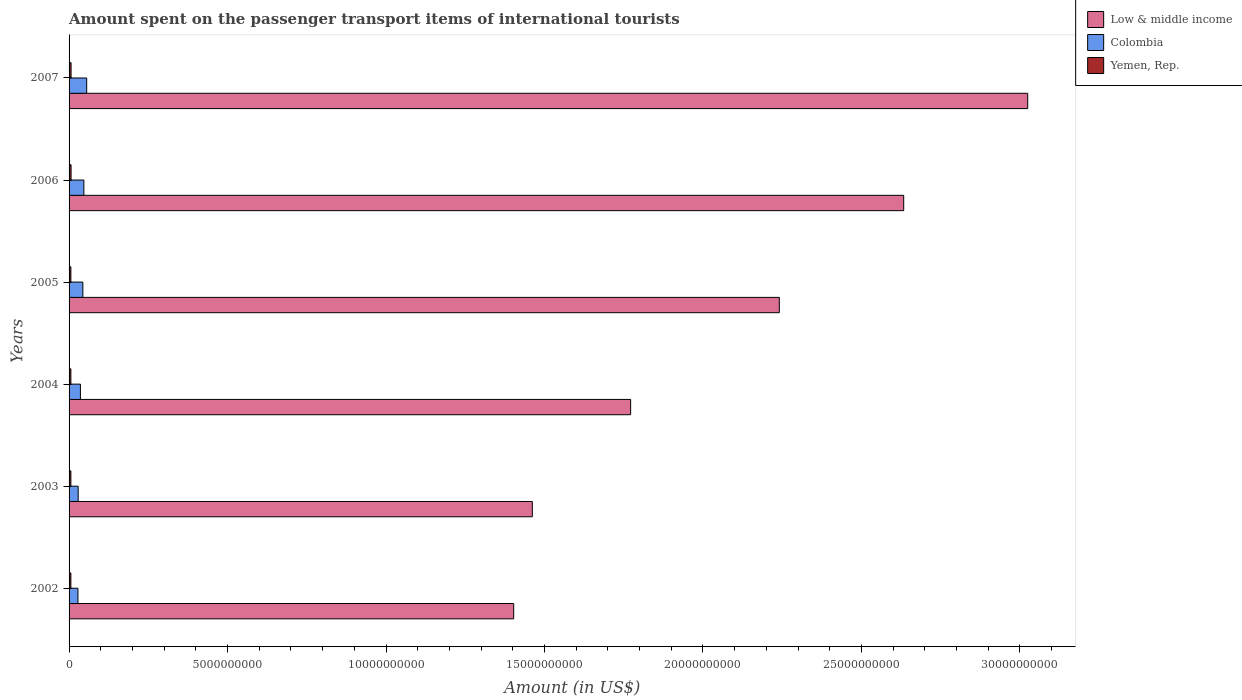How many different coloured bars are there?
Keep it short and to the point. 3. How many groups of bars are there?
Your answer should be very brief. 6. Are the number of bars per tick equal to the number of legend labels?
Provide a succinct answer. Yes. Are the number of bars on each tick of the Y-axis equal?
Make the answer very short. Yes. What is the amount spent on the passenger transport items of international tourists in Low & middle income in 2006?
Offer a terse response. 2.63e+1. Across all years, what is the maximum amount spent on the passenger transport items of international tourists in Low & middle income?
Provide a short and direct response. 3.02e+1. Across all years, what is the minimum amount spent on the passenger transport items of international tourists in Low & middle income?
Provide a succinct answer. 1.40e+1. In which year was the amount spent on the passenger transport items of international tourists in Yemen, Rep. maximum?
Offer a very short reply. 2006. What is the total amount spent on the passenger transport items of international tourists in Low & middle income in the graph?
Provide a short and direct response. 1.25e+11. What is the difference between the amount spent on the passenger transport items of international tourists in Low & middle income in 2005 and that in 2007?
Give a very brief answer. -7.84e+09. What is the difference between the amount spent on the passenger transport items of international tourists in Yemen, Rep. in 2005 and the amount spent on the passenger transport items of international tourists in Colombia in 2007?
Offer a very short reply. -4.99e+08. What is the average amount spent on the passenger transport items of international tourists in Yemen, Rep. per year?
Ensure brevity in your answer.  5.90e+07. In the year 2004, what is the difference between the amount spent on the passenger transport items of international tourists in Yemen, Rep. and amount spent on the passenger transport items of international tourists in Low & middle income?
Your response must be concise. -1.77e+1. In how many years, is the amount spent on the passenger transport items of international tourists in Yemen, Rep. greater than 3000000000 US$?
Ensure brevity in your answer.  0. What is the ratio of the amount spent on the passenger transport items of international tourists in Low & middle income in 2002 to that in 2003?
Your answer should be very brief. 0.96. Is the amount spent on the passenger transport items of international tourists in Colombia in 2003 less than that in 2005?
Your answer should be compact. Yes. What is the difference between the highest and the second highest amount spent on the passenger transport items of international tourists in Colombia?
Offer a terse response. 8.90e+07. What is the difference between the highest and the lowest amount spent on the passenger transport items of international tourists in Yemen, Rep.?
Provide a succinct answer. 6.00e+06. In how many years, is the amount spent on the passenger transport items of international tourists in Yemen, Rep. greater than the average amount spent on the passenger transport items of international tourists in Yemen, Rep. taken over all years?
Ensure brevity in your answer.  2. What does the 3rd bar from the top in 2007 represents?
Offer a very short reply. Low & middle income. What does the 3rd bar from the bottom in 2007 represents?
Make the answer very short. Yemen, Rep. How many bars are there?
Offer a terse response. 18. Are all the bars in the graph horizontal?
Offer a very short reply. Yes. Does the graph contain any zero values?
Provide a short and direct response. No. Does the graph contain grids?
Give a very brief answer. No. How many legend labels are there?
Your response must be concise. 3. What is the title of the graph?
Give a very brief answer. Amount spent on the passenger transport items of international tourists. What is the label or title of the X-axis?
Your response must be concise. Amount (in US$). What is the Amount (in US$) of Low & middle income in 2002?
Offer a very short reply. 1.40e+1. What is the Amount (in US$) of Colombia in 2002?
Keep it short and to the point. 2.80e+08. What is the Amount (in US$) of Yemen, Rep. in 2002?
Ensure brevity in your answer.  5.70e+07. What is the Amount (in US$) in Low & middle income in 2003?
Offer a very short reply. 1.46e+1. What is the Amount (in US$) in Colombia in 2003?
Your answer should be very brief. 2.87e+08. What is the Amount (in US$) of Yemen, Rep. in 2003?
Offer a terse response. 5.70e+07. What is the Amount (in US$) of Low & middle income in 2004?
Offer a very short reply. 1.77e+1. What is the Amount (in US$) of Colombia in 2004?
Keep it short and to the point. 3.58e+08. What is the Amount (in US$) of Yemen, Rep. in 2004?
Keep it short and to the point. 5.70e+07. What is the Amount (in US$) of Low & middle income in 2005?
Ensure brevity in your answer.  2.24e+1. What is the Amount (in US$) in Colombia in 2005?
Keep it short and to the point. 4.35e+08. What is the Amount (in US$) in Yemen, Rep. in 2005?
Offer a terse response. 5.70e+07. What is the Amount (in US$) in Low & middle income in 2006?
Keep it short and to the point. 2.63e+1. What is the Amount (in US$) in Colombia in 2006?
Make the answer very short. 4.67e+08. What is the Amount (in US$) in Yemen, Rep. in 2006?
Keep it short and to the point. 6.30e+07. What is the Amount (in US$) of Low & middle income in 2007?
Make the answer very short. 3.02e+1. What is the Amount (in US$) in Colombia in 2007?
Give a very brief answer. 5.56e+08. What is the Amount (in US$) of Yemen, Rep. in 2007?
Your answer should be compact. 6.30e+07. Across all years, what is the maximum Amount (in US$) in Low & middle income?
Your response must be concise. 3.02e+1. Across all years, what is the maximum Amount (in US$) in Colombia?
Offer a terse response. 5.56e+08. Across all years, what is the maximum Amount (in US$) in Yemen, Rep.?
Provide a short and direct response. 6.30e+07. Across all years, what is the minimum Amount (in US$) in Low & middle income?
Your answer should be compact. 1.40e+1. Across all years, what is the minimum Amount (in US$) in Colombia?
Offer a very short reply. 2.80e+08. Across all years, what is the minimum Amount (in US$) in Yemen, Rep.?
Your response must be concise. 5.70e+07. What is the total Amount (in US$) in Low & middle income in the graph?
Provide a short and direct response. 1.25e+11. What is the total Amount (in US$) in Colombia in the graph?
Give a very brief answer. 2.38e+09. What is the total Amount (in US$) in Yemen, Rep. in the graph?
Offer a very short reply. 3.54e+08. What is the difference between the Amount (in US$) of Low & middle income in 2002 and that in 2003?
Keep it short and to the point. -5.88e+08. What is the difference between the Amount (in US$) of Colombia in 2002 and that in 2003?
Make the answer very short. -7.00e+06. What is the difference between the Amount (in US$) in Yemen, Rep. in 2002 and that in 2003?
Make the answer very short. 0. What is the difference between the Amount (in US$) in Low & middle income in 2002 and that in 2004?
Give a very brief answer. -3.69e+09. What is the difference between the Amount (in US$) of Colombia in 2002 and that in 2004?
Provide a succinct answer. -7.80e+07. What is the difference between the Amount (in US$) of Low & middle income in 2002 and that in 2005?
Your answer should be very brief. -8.38e+09. What is the difference between the Amount (in US$) of Colombia in 2002 and that in 2005?
Your response must be concise. -1.55e+08. What is the difference between the Amount (in US$) of Low & middle income in 2002 and that in 2006?
Your answer should be compact. -1.23e+1. What is the difference between the Amount (in US$) in Colombia in 2002 and that in 2006?
Your answer should be compact. -1.87e+08. What is the difference between the Amount (in US$) in Yemen, Rep. in 2002 and that in 2006?
Provide a short and direct response. -6.00e+06. What is the difference between the Amount (in US$) of Low & middle income in 2002 and that in 2007?
Make the answer very short. -1.62e+1. What is the difference between the Amount (in US$) of Colombia in 2002 and that in 2007?
Ensure brevity in your answer.  -2.76e+08. What is the difference between the Amount (in US$) in Yemen, Rep. in 2002 and that in 2007?
Keep it short and to the point. -6.00e+06. What is the difference between the Amount (in US$) of Low & middle income in 2003 and that in 2004?
Give a very brief answer. -3.10e+09. What is the difference between the Amount (in US$) of Colombia in 2003 and that in 2004?
Your answer should be compact. -7.10e+07. What is the difference between the Amount (in US$) in Yemen, Rep. in 2003 and that in 2004?
Your answer should be very brief. 0. What is the difference between the Amount (in US$) of Low & middle income in 2003 and that in 2005?
Provide a short and direct response. -7.79e+09. What is the difference between the Amount (in US$) in Colombia in 2003 and that in 2005?
Your response must be concise. -1.48e+08. What is the difference between the Amount (in US$) in Low & middle income in 2003 and that in 2006?
Provide a short and direct response. -1.17e+1. What is the difference between the Amount (in US$) of Colombia in 2003 and that in 2006?
Your answer should be compact. -1.80e+08. What is the difference between the Amount (in US$) of Yemen, Rep. in 2003 and that in 2006?
Keep it short and to the point. -6.00e+06. What is the difference between the Amount (in US$) in Low & middle income in 2003 and that in 2007?
Provide a short and direct response. -1.56e+1. What is the difference between the Amount (in US$) in Colombia in 2003 and that in 2007?
Provide a succinct answer. -2.69e+08. What is the difference between the Amount (in US$) of Yemen, Rep. in 2003 and that in 2007?
Offer a terse response. -6.00e+06. What is the difference between the Amount (in US$) of Low & middle income in 2004 and that in 2005?
Offer a terse response. -4.69e+09. What is the difference between the Amount (in US$) in Colombia in 2004 and that in 2005?
Make the answer very short. -7.70e+07. What is the difference between the Amount (in US$) in Low & middle income in 2004 and that in 2006?
Make the answer very short. -8.62e+09. What is the difference between the Amount (in US$) of Colombia in 2004 and that in 2006?
Ensure brevity in your answer.  -1.09e+08. What is the difference between the Amount (in US$) in Yemen, Rep. in 2004 and that in 2006?
Offer a terse response. -6.00e+06. What is the difference between the Amount (in US$) of Low & middle income in 2004 and that in 2007?
Your answer should be very brief. -1.25e+1. What is the difference between the Amount (in US$) in Colombia in 2004 and that in 2007?
Your response must be concise. -1.98e+08. What is the difference between the Amount (in US$) in Yemen, Rep. in 2004 and that in 2007?
Provide a short and direct response. -6.00e+06. What is the difference between the Amount (in US$) in Low & middle income in 2005 and that in 2006?
Ensure brevity in your answer.  -3.92e+09. What is the difference between the Amount (in US$) of Colombia in 2005 and that in 2006?
Your answer should be compact. -3.20e+07. What is the difference between the Amount (in US$) in Yemen, Rep. in 2005 and that in 2006?
Provide a succinct answer. -6.00e+06. What is the difference between the Amount (in US$) of Low & middle income in 2005 and that in 2007?
Make the answer very short. -7.84e+09. What is the difference between the Amount (in US$) of Colombia in 2005 and that in 2007?
Offer a terse response. -1.21e+08. What is the difference between the Amount (in US$) of Yemen, Rep. in 2005 and that in 2007?
Provide a succinct answer. -6.00e+06. What is the difference between the Amount (in US$) in Low & middle income in 2006 and that in 2007?
Provide a succinct answer. -3.91e+09. What is the difference between the Amount (in US$) in Colombia in 2006 and that in 2007?
Keep it short and to the point. -8.90e+07. What is the difference between the Amount (in US$) in Yemen, Rep. in 2006 and that in 2007?
Your answer should be compact. 0. What is the difference between the Amount (in US$) in Low & middle income in 2002 and the Amount (in US$) in Colombia in 2003?
Your response must be concise. 1.37e+1. What is the difference between the Amount (in US$) in Low & middle income in 2002 and the Amount (in US$) in Yemen, Rep. in 2003?
Offer a very short reply. 1.40e+1. What is the difference between the Amount (in US$) in Colombia in 2002 and the Amount (in US$) in Yemen, Rep. in 2003?
Keep it short and to the point. 2.23e+08. What is the difference between the Amount (in US$) of Low & middle income in 2002 and the Amount (in US$) of Colombia in 2004?
Your response must be concise. 1.37e+1. What is the difference between the Amount (in US$) in Low & middle income in 2002 and the Amount (in US$) in Yemen, Rep. in 2004?
Your response must be concise. 1.40e+1. What is the difference between the Amount (in US$) in Colombia in 2002 and the Amount (in US$) in Yemen, Rep. in 2004?
Your answer should be compact. 2.23e+08. What is the difference between the Amount (in US$) of Low & middle income in 2002 and the Amount (in US$) of Colombia in 2005?
Your response must be concise. 1.36e+1. What is the difference between the Amount (in US$) in Low & middle income in 2002 and the Amount (in US$) in Yemen, Rep. in 2005?
Your response must be concise. 1.40e+1. What is the difference between the Amount (in US$) of Colombia in 2002 and the Amount (in US$) of Yemen, Rep. in 2005?
Your answer should be very brief. 2.23e+08. What is the difference between the Amount (in US$) of Low & middle income in 2002 and the Amount (in US$) of Colombia in 2006?
Provide a short and direct response. 1.36e+1. What is the difference between the Amount (in US$) of Low & middle income in 2002 and the Amount (in US$) of Yemen, Rep. in 2006?
Make the answer very short. 1.40e+1. What is the difference between the Amount (in US$) in Colombia in 2002 and the Amount (in US$) in Yemen, Rep. in 2006?
Provide a short and direct response. 2.17e+08. What is the difference between the Amount (in US$) of Low & middle income in 2002 and the Amount (in US$) of Colombia in 2007?
Ensure brevity in your answer.  1.35e+1. What is the difference between the Amount (in US$) in Low & middle income in 2002 and the Amount (in US$) in Yemen, Rep. in 2007?
Give a very brief answer. 1.40e+1. What is the difference between the Amount (in US$) in Colombia in 2002 and the Amount (in US$) in Yemen, Rep. in 2007?
Make the answer very short. 2.17e+08. What is the difference between the Amount (in US$) in Low & middle income in 2003 and the Amount (in US$) in Colombia in 2004?
Give a very brief answer. 1.43e+1. What is the difference between the Amount (in US$) in Low & middle income in 2003 and the Amount (in US$) in Yemen, Rep. in 2004?
Offer a terse response. 1.46e+1. What is the difference between the Amount (in US$) in Colombia in 2003 and the Amount (in US$) in Yemen, Rep. in 2004?
Make the answer very short. 2.30e+08. What is the difference between the Amount (in US$) in Low & middle income in 2003 and the Amount (in US$) in Colombia in 2005?
Provide a succinct answer. 1.42e+1. What is the difference between the Amount (in US$) of Low & middle income in 2003 and the Amount (in US$) of Yemen, Rep. in 2005?
Give a very brief answer. 1.46e+1. What is the difference between the Amount (in US$) of Colombia in 2003 and the Amount (in US$) of Yemen, Rep. in 2005?
Offer a terse response. 2.30e+08. What is the difference between the Amount (in US$) in Low & middle income in 2003 and the Amount (in US$) in Colombia in 2006?
Ensure brevity in your answer.  1.42e+1. What is the difference between the Amount (in US$) in Low & middle income in 2003 and the Amount (in US$) in Yemen, Rep. in 2006?
Keep it short and to the point. 1.46e+1. What is the difference between the Amount (in US$) of Colombia in 2003 and the Amount (in US$) of Yemen, Rep. in 2006?
Give a very brief answer. 2.24e+08. What is the difference between the Amount (in US$) of Low & middle income in 2003 and the Amount (in US$) of Colombia in 2007?
Your response must be concise. 1.41e+1. What is the difference between the Amount (in US$) in Low & middle income in 2003 and the Amount (in US$) in Yemen, Rep. in 2007?
Offer a terse response. 1.46e+1. What is the difference between the Amount (in US$) of Colombia in 2003 and the Amount (in US$) of Yemen, Rep. in 2007?
Keep it short and to the point. 2.24e+08. What is the difference between the Amount (in US$) of Low & middle income in 2004 and the Amount (in US$) of Colombia in 2005?
Your answer should be compact. 1.73e+1. What is the difference between the Amount (in US$) of Low & middle income in 2004 and the Amount (in US$) of Yemen, Rep. in 2005?
Offer a terse response. 1.77e+1. What is the difference between the Amount (in US$) in Colombia in 2004 and the Amount (in US$) in Yemen, Rep. in 2005?
Offer a very short reply. 3.01e+08. What is the difference between the Amount (in US$) of Low & middle income in 2004 and the Amount (in US$) of Colombia in 2006?
Your answer should be compact. 1.73e+1. What is the difference between the Amount (in US$) of Low & middle income in 2004 and the Amount (in US$) of Yemen, Rep. in 2006?
Your answer should be very brief. 1.77e+1. What is the difference between the Amount (in US$) in Colombia in 2004 and the Amount (in US$) in Yemen, Rep. in 2006?
Give a very brief answer. 2.95e+08. What is the difference between the Amount (in US$) in Low & middle income in 2004 and the Amount (in US$) in Colombia in 2007?
Provide a succinct answer. 1.72e+1. What is the difference between the Amount (in US$) in Low & middle income in 2004 and the Amount (in US$) in Yemen, Rep. in 2007?
Provide a short and direct response. 1.77e+1. What is the difference between the Amount (in US$) of Colombia in 2004 and the Amount (in US$) of Yemen, Rep. in 2007?
Offer a very short reply. 2.95e+08. What is the difference between the Amount (in US$) in Low & middle income in 2005 and the Amount (in US$) in Colombia in 2006?
Provide a short and direct response. 2.19e+1. What is the difference between the Amount (in US$) of Low & middle income in 2005 and the Amount (in US$) of Yemen, Rep. in 2006?
Your response must be concise. 2.23e+1. What is the difference between the Amount (in US$) in Colombia in 2005 and the Amount (in US$) in Yemen, Rep. in 2006?
Your response must be concise. 3.72e+08. What is the difference between the Amount (in US$) in Low & middle income in 2005 and the Amount (in US$) in Colombia in 2007?
Provide a succinct answer. 2.19e+1. What is the difference between the Amount (in US$) of Low & middle income in 2005 and the Amount (in US$) of Yemen, Rep. in 2007?
Ensure brevity in your answer.  2.23e+1. What is the difference between the Amount (in US$) of Colombia in 2005 and the Amount (in US$) of Yemen, Rep. in 2007?
Make the answer very short. 3.72e+08. What is the difference between the Amount (in US$) of Low & middle income in 2006 and the Amount (in US$) of Colombia in 2007?
Provide a succinct answer. 2.58e+1. What is the difference between the Amount (in US$) in Low & middle income in 2006 and the Amount (in US$) in Yemen, Rep. in 2007?
Keep it short and to the point. 2.63e+1. What is the difference between the Amount (in US$) in Colombia in 2006 and the Amount (in US$) in Yemen, Rep. in 2007?
Your answer should be very brief. 4.04e+08. What is the average Amount (in US$) of Low & middle income per year?
Offer a terse response. 2.09e+1. What is the average Amount (in US$) in Colombia per year?
Offer a terse response. 3.97e+08. What is the average Amount (in US$) of Yemen, Rep. per year?
Keep it short and to the point. 5.90e+07. In the year 2002, what is the difference between the Amount (in US$) in Low & middle income and Amount (in US$) in Colombia?
Provide a succinct answer. 1.37e+1. In the year 2002, what is the difference between the Amount (in US$) in Low & middle income and Amount (in US$) in Yemen, Rep.?
Make the answer very short. 1.40e+1. In the year 2002, what is the difference between the Amount (in US$) of Colombia and Amount (in US$) of Yemen, Rep.?
Your answer should be very brief. 2.23e+08. In the year 2003, what is the difference between the Amount (in US$) of Low & middle income and Amount (in US$) of Colombia?
Make the answer very short. 1.43e+1. In the year 2003, what is the difference between the Amount (in US$) of Low & middle income and Amount (in US$) of Yemen, Rep.?
Give a very brief answer. 1.46e+1. In the year 2003, what is the difference between the Amount (in US$) in Colombia and Amount (in US$) in Yemen, Rep.?
Your answer should be very brief. 2.30e+08. In the year 2004, what is the difference between the Amount (in US$) in Low & middle income and Amount (in US$) in Colombia?
Make the answer very short. 1.74e+1. In the year 2004, what is the difference between the Amount (in US$) of Low & middle income and Amount (in US$) of Yemen, Rep.?
Provide a succinct answer. 1.77e+1. In the year 2004, what is the difference between the Amount (in US$) in Colombia and Amount (in US$) in Yemen, Rep.?
Provide a short and direct response. 3.01e+08. In the year 2005, what is the difference between the Amount (in US$) in Low & middle income and Amount (in US$) in Colombia?
Make the answer very short. 2.20e+1. In the year 2005, what is the difference between the Amount (in US$) in Low & middle income and Amount (in US$) in Yemen, Rep.?
Provide a short and direct response. 2.24e+1. In the year 2005, what is the difference between the Amount (in US$) of Colombia and Amount (in US$) of Yemen, Rep.?
Your response must be concise. 3.78e+08. In the year 2006, what is the difference between the Amount (in US$) in Low & middle income and Amount (in US$) in Colombia?
Provide a succinct answer. 2.59e+1. In the year 2006, what is the difference between the Amount (in US$) in Low & middle income and Amount (in US$) in Yemen, Rep.?
Give a very brief answer. 2.63e+1. In the year 2006, what is the difference between the Amount (in US$) of Colombia and Amount (in US$) of Yemen, Rep.?
Your answer should be compact. 4.04e+08. In the year 2007, what is the difference between the Amount (in US$) of Low & middle income and Amount (in US$) of Colombia?
Keep it short and to the point. 2.97e+1. In the year 2007, what is the difference between the Amount (in US$) of Low & middle income and Amount (in US$) of Yemen, Rep.?
Your response must be concise. 3.02e+1. In the year 2007, what is the difference between the Amount (in US$) of Colombia and Amount (in US$) of Yemen, Rep.?
Provide a short and direct response. 4.93e+08. What is the ratio of the Amount (in US$) of Low & middle income in 2002 to that in 2003?
Make the answer very short. 0.96. What is the ratio of the Amount (in US$) in Colombia in 2002 to that in 2003?
Ensure brevity in your answer.  0.98. What is the ratio of the Amount (in US$) of Yemen, Rep. in 2002 to that in 2003?
Give a very brief answer. 1. What is the ratio of the Amount (in US$) of Low & middle income in 2002 to that in 2004?
Your answer should be compact. 0.79. What is the ratio of the Amount (in US$) in Colombia in 2002 to that in 2004?
Your response must be concise. 0.78. What is the ratio of the Amount (in US$) in Low & middle income in 2002 to that in 2005?
Provide a short and direct response. 0.63. What is the ratio of the Amount (in US$) of Colombia in 2002 to that in 2005?
Ensure brevity in your answer.  0.64. What is the ratio of the Amount (in US$) in Yemen, Rep. in 2002 to that in 2005?
Your answer should be very brief. 1. What is the ratio of the Amount (in US$) in Low & middle income in 2002 to that in 2006?
Make the answer very short. 0.53. What is the ratio of the Amount (in US$) of Colombia in 2002 to that in 2006?
Make the answer very short. 0.6. What is the ratio of the Amount (in US$) in Yemen, Rep. in 2002 to that in 2006?
Make the answer very short. 0.9. What is the ratio of the Amount (in US$) of Low & middle income in 2002 to that in 2007?
Your answer should be very brief. 0.46. What is the ratio of the Amount (in US$) of Colombia in 2002 to that in 2007?
Your response must be concise. 0.5. What is the ratio of the Amount (in US$) of Yemen, Rep. in 2002 to that in 2007?
Make the answer very short. 0.9. What is the ratio of the Amount (in US$) of Low & middle income in 2003 to that in 2004?
Ensure brevity in your answer.  0.82. What is the ratio of the Amount (in US$) of Colombia in 2003 to that in 2004?
Make the answer very short. 0.8. What is the ratio of the Amount (in US$) in Yemen, Rep. in 2003 to that in 2004?
Make the answer very short. 1. What is the ratio of the Amount (in US$) in Low & middle income in 2003 to that in 2005?
Keep it short and to the point. 0.65. What is the ratio of the Amount (in US$) in Colombia in 2003 to that in 2005?
Provide a succinct answer. 0.66. What is the ratio of the Amount (in US$) of Low & middle income in 2003 to that in 2006?
Your answer should be compact. 0.56. What is the ratio of the Amount (in US$) in Colombia in 2003 to that in 2006?
Ensure brevity in your answer.  0.61. What is the ratio of the Amount (in US$) in Yemen, Rep. in 2003 to that in 2006?
Provide a succinct answer. 0.9. What is the ratio of the Amount (in US$) of Low & middle income in 2003 to that in 2007?
Offer a very short reply. 0.48. What is the ratio of the Amount (in US$) in Colombia in 2003 to that in 2007?
Keep it short and to the point. 0.52. What is the ratio of the Amount (in US$) of Yemen, Rep. in 2003 to that in 2007?
Offer a terse response. 0.9. What is the ratio of the Amount (in US$) in Low & middle income in 2004 to that in 2005?
Make the answer very short. 0.79. What is the ratio of the Amount (in US$) of Colombia in 2004 to that in 2005?
Your answer should be very brief. 0.82. What is the ratio of the Amount (in US$) of Low & middle income in 2004 to that in 2006?
Give a very brief answer. 0.67. What is the ratio of the Amount (in US$) of Colombia in 2004 to that in 2006?
Ensure brevity in your answer.  0.77. What is the ratio of the Amount (in US$) of Yemen, Rep. in 2004 to that in 2006?
Give a very brief answer. 0.9. What is the ratio of the Amount (in US$) of Low & middle income in 2004 to that in 2007?
Your answer should be compact. 0.59. What is the ratio of the Amount (in US$) of Colombia in 2004 to that in 2007?
Your answer should be very brief. 0.64. What is the ratio of the Amount (in US$) of Yemen, Rep. in 2004 to that in 2007?
Your answer should be compact. 0.9. What is the ratio of the Amount (in US$) of Low & middle income in 2005 to that in 2006?
Keep it short and to the point. 0.85. What is the ratio of the Amount (in US$) in Colombia in 2005 to that in 2006?
Give a very brief answer. 0.93. What is the ratio of the Amount (in US$) in Yemen, Rep. in 2005 to that in 2006?
Provide a succinct answer. 0.9. What is the ratio of the Amount (in US$) in Low & middle income in 2005 to that in 2007?
Provide a short and direct response. 0.74. What is the ratio of the Amount (in US$) of Colombia in 2005 to that in 2007?
Give a very brief answer. 0.78. What is the ratio of the Amount (in US$) in Yemen, Rep. in 2005 to that in 2007?
Ensure brevity in your answer.  0.9. What is the ratio of the Amount (in US$) of Low & middle income in 2006 to that in 2007?
Make the answer very short. 0.87. What is the ratio of the Amount (in US$) in Colombia in 2006 to that in 2007?
Make the answer very short. 0.84. What is the ratio of the Amount (in US$) in Yemen, Rep. in 2006 to that in 2007?
Keep it short and to the point. 1. What is the difference between the highest and the second highest Amount (in US$) of Low & middle income?
Provide a short and direct response. 3.91e+09. What is the difference between the highest and the second highest Amount (in US$) of Colombia?
Offer a terse response. 8.90e+07. What is the difference between the highest and the lowest Amount (in US$) of Low & middle income?
Keep it short and to the point. 1.62e+1. What is the difference between the highest and the lowest Amount (in US$) in Colombia?
Keep it short and to the point. 2.76e+08. 